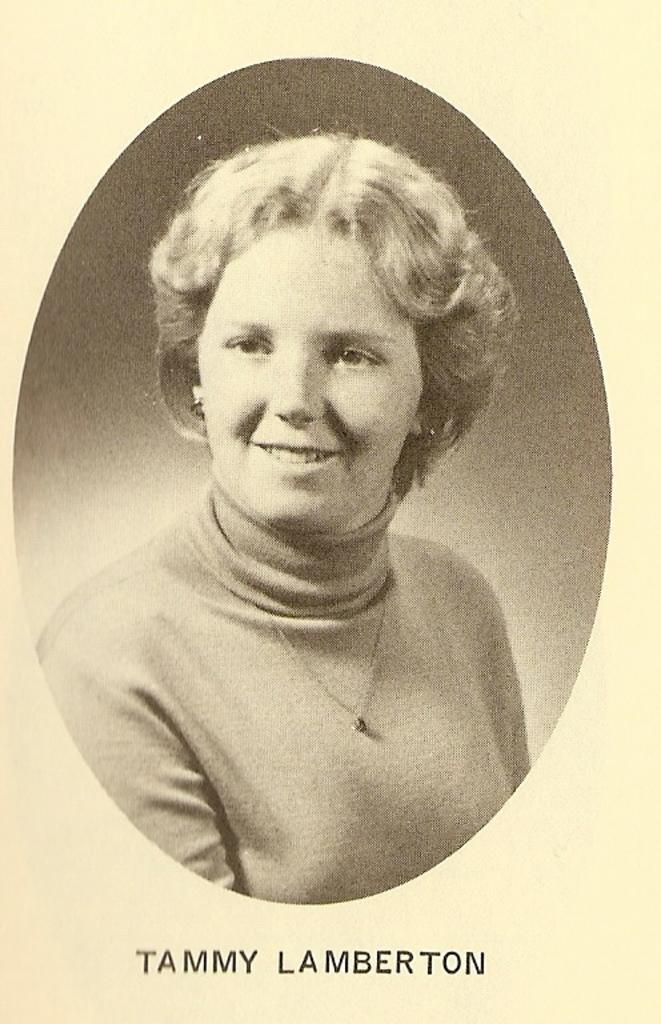Who or what is present in the image? There is a person in the image. What can be observed about the person's attire? The person is wearing clothes. What additional information can be found at the bottom of the image? There is text at the bottom of the image. What type of cart can be seen in the image? There is no cart present in the image; it features a person wearing clothes and text at the bottom. Can you tell me which vein the person is using to read the text in the image? There is no indication of the person reading any text in the image, and veins are not visible. 